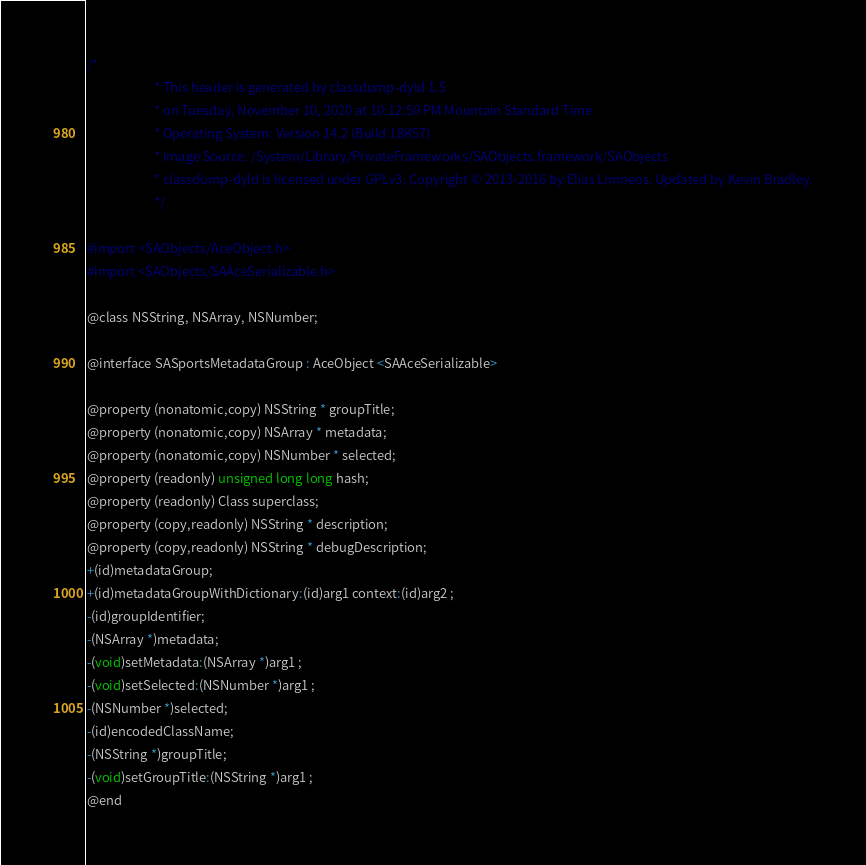Convert code to text. <code><loc_0><loc_0><loc_500><loc_500><_C_>/*
                       * This header is generated by classdump-dyld 1.5
                       * on Tuesday, November 10, 2020 at 10:12:50 PM Mountain Standard Time
                       * Operating System: Version 14.2 (Build 18K57)
                       * Image Source: /System/Library/PrivateFrameworks/SAObjects.framework/SAObjects
                       * classdump-dyld is licensed under GPLv3, Copyright © 2013-2016 by Elias Limneos. Updated by Kevin Bradley.
                       */

#import <SAObjects/AceObject.h>
#import <SAObjects/SAAceSerializable.h>

@class NSString, NSArray, NSNumber;

@interface SASportsMetadataGroup : AceObject <SAAceSerializable>

@property (nonatomic,copy) NSString * groupTitle; 
@property (nonatomic,copy) NSArray * metadata; 
@property (nonatomic,copy) NSNumber * selected; 
@property (readonly) unsigned long long hash; 
@property (readonly) Class superclass; 
@property (copy,readonly) NSString * description; 
@property (copy,readonly) NSString * debugDescription; 
+(id)metadataGroup;
+(id)metadataGroupWithDictionary:(id)arg1 context:(id)arg2 ;
-(id)groupIdentifier;
-(NSArray *)metadata;
-(void)setMetadata:(NSArray *)arg1 ;
-(void)setSelected:(NSNumber *)arg1 ;
-(NSNumber *)selected;
-(id)encodedClassName;
-(NSString *)groupTitle;
-(void)setGroupTitle:(NSString *)arg1 ;
@end

</code> 